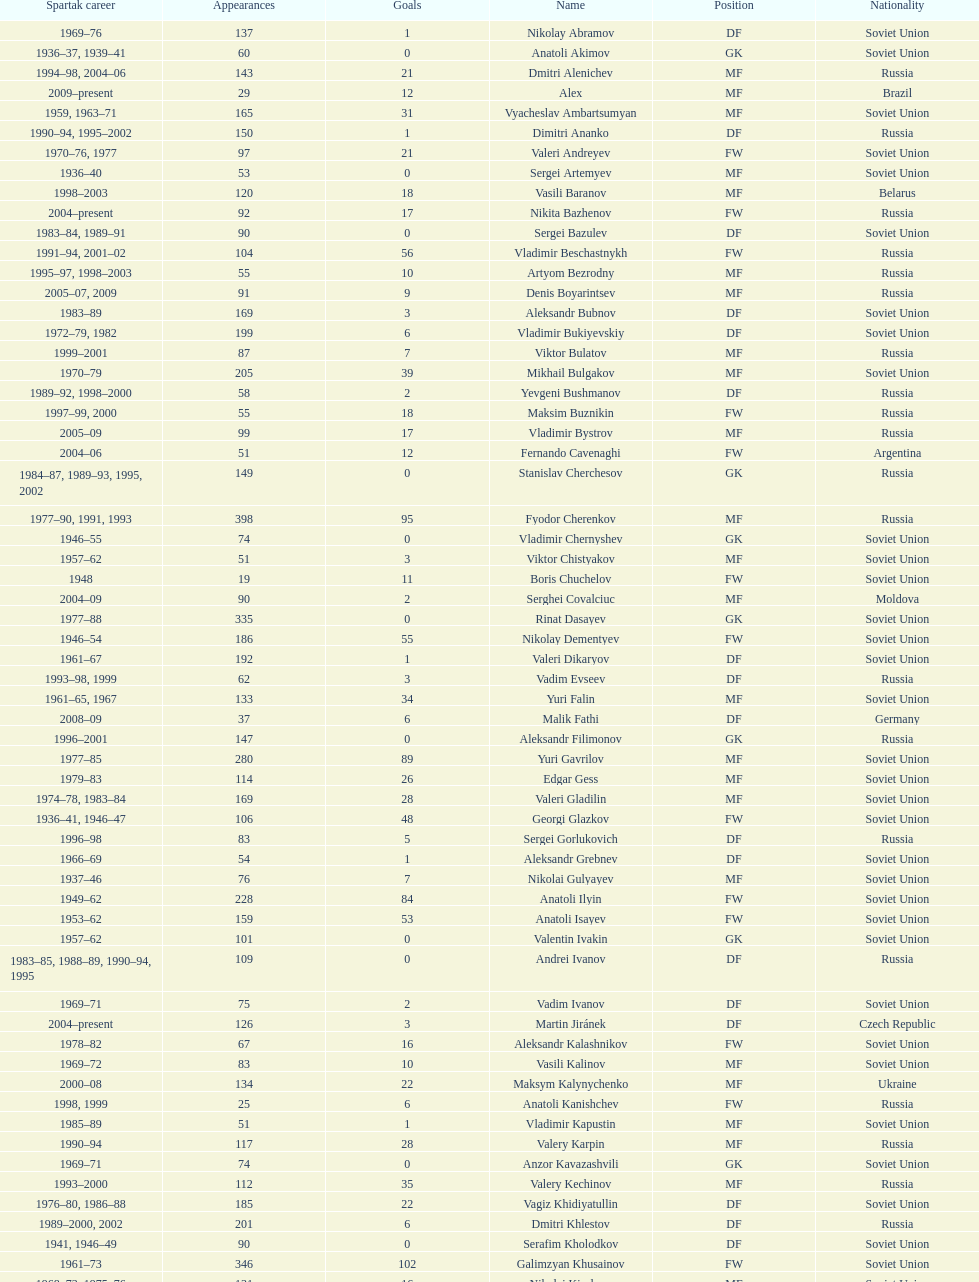Which player has the most appearances with the club? Fyodor Cherenkov. 